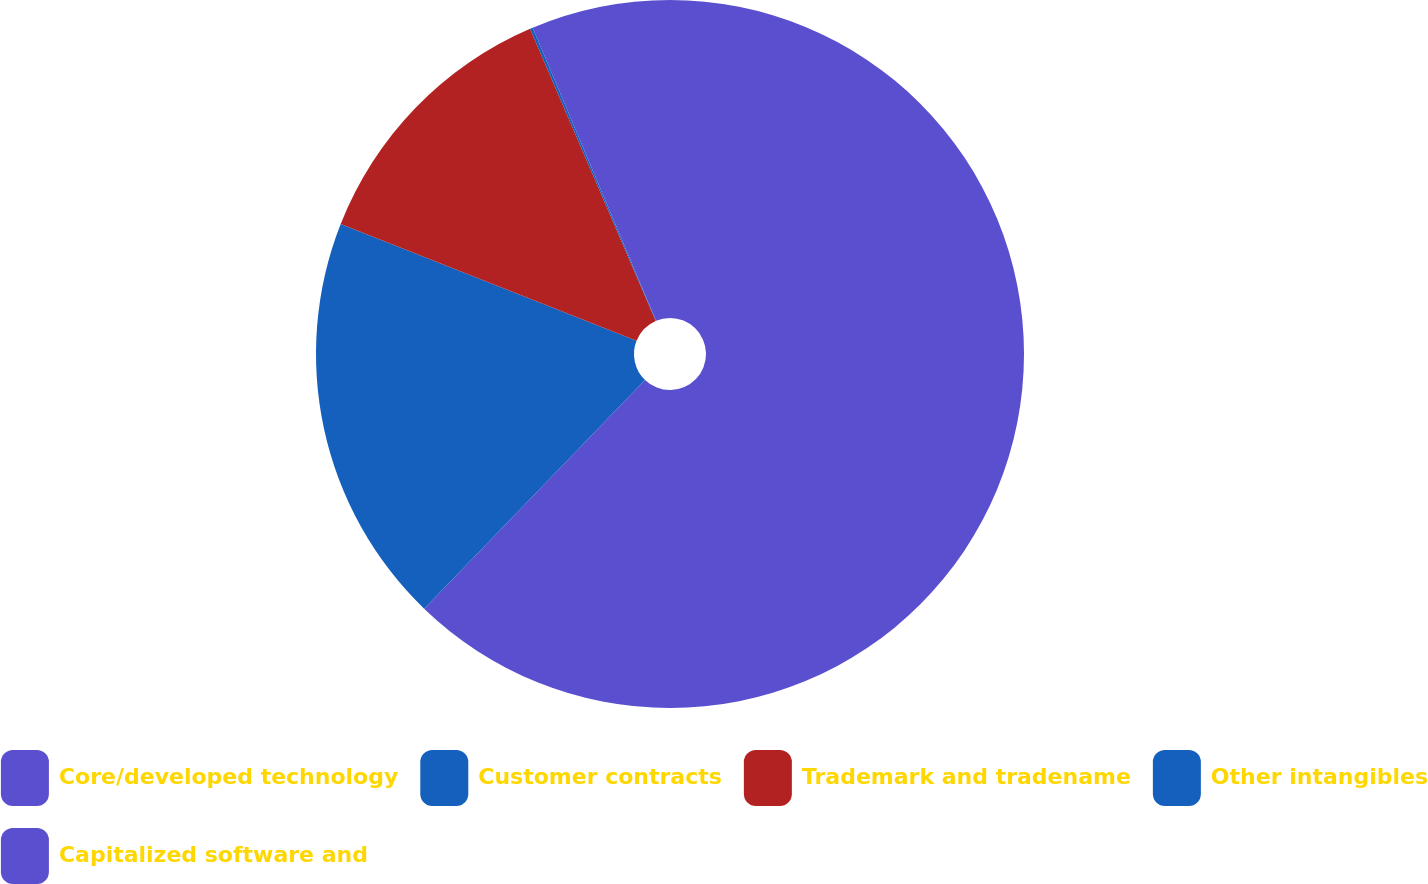Convert chart to OTSL. <chart><loc_0><loc_0><loc_500><loc_500><pie_chart><fcel>Core/developed technology<fcel>Customer contracts<fcel>Trademark and tradename<fcel>Other intangibles<fcel>Capitalized software and<nl><fcel>62.22%<fcel>18.76%<fcel>12.55%<fcel>0.13%<fcel>6.34%<nl></chart> 